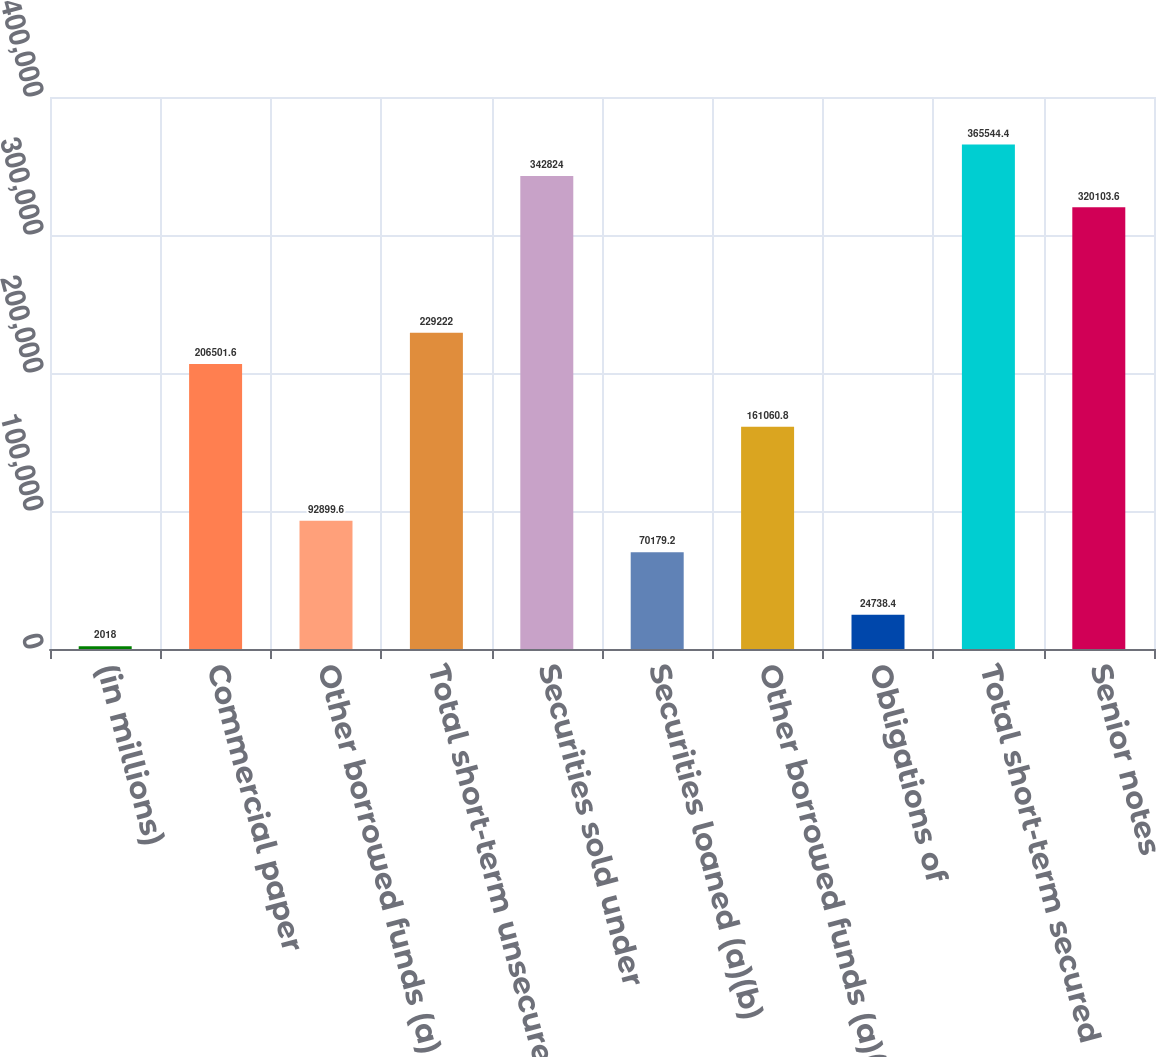Convert chart. <chart><loc_0><loc_0><loc_500><loc_500><bar_chart><fcel>(in millions)<fcel>Commercial paper<fcel>Other borrowed funds (a)<fcel>Total short-term unsecured<fcel>Securities sold under<fcel>Securities loaned (a)(b)<fcel>Other borrowed funds (a)(c)<fcel>Obligations of<fcel>Total short-term secured<fcel>Senior notes<nl><fcel>2018<fcel>206502<fcel>92899.6<fcel>229222<fcel>342824<fcel>70179.2<fcel>161061<fcel>24738.4<fcel>365544<fcel>320104<nl></chart> 